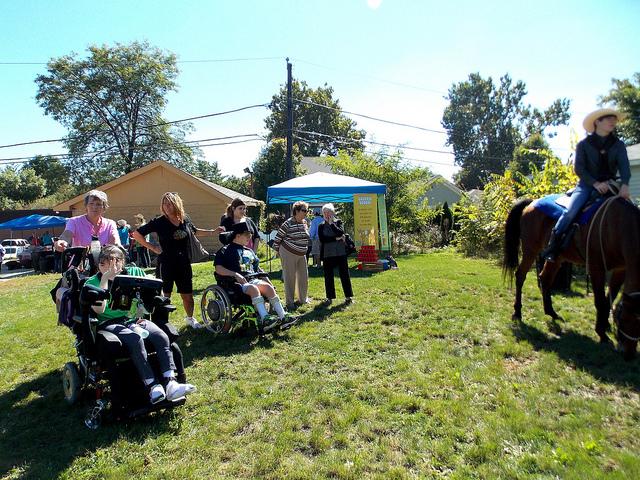Is the kid on the horse wearing a sombrero?
Give a very brief answer. No. Are these people aristocrats?
Give a very brief answer. No. How are the women protected from the sun?
Quick response, please. Hat. How many people are in a wheelchair?
Write a very short answer. 2. How many people are riding an animal?
Give a very brief answer. 1. What is the man on?
Keep it brief. Horse. 